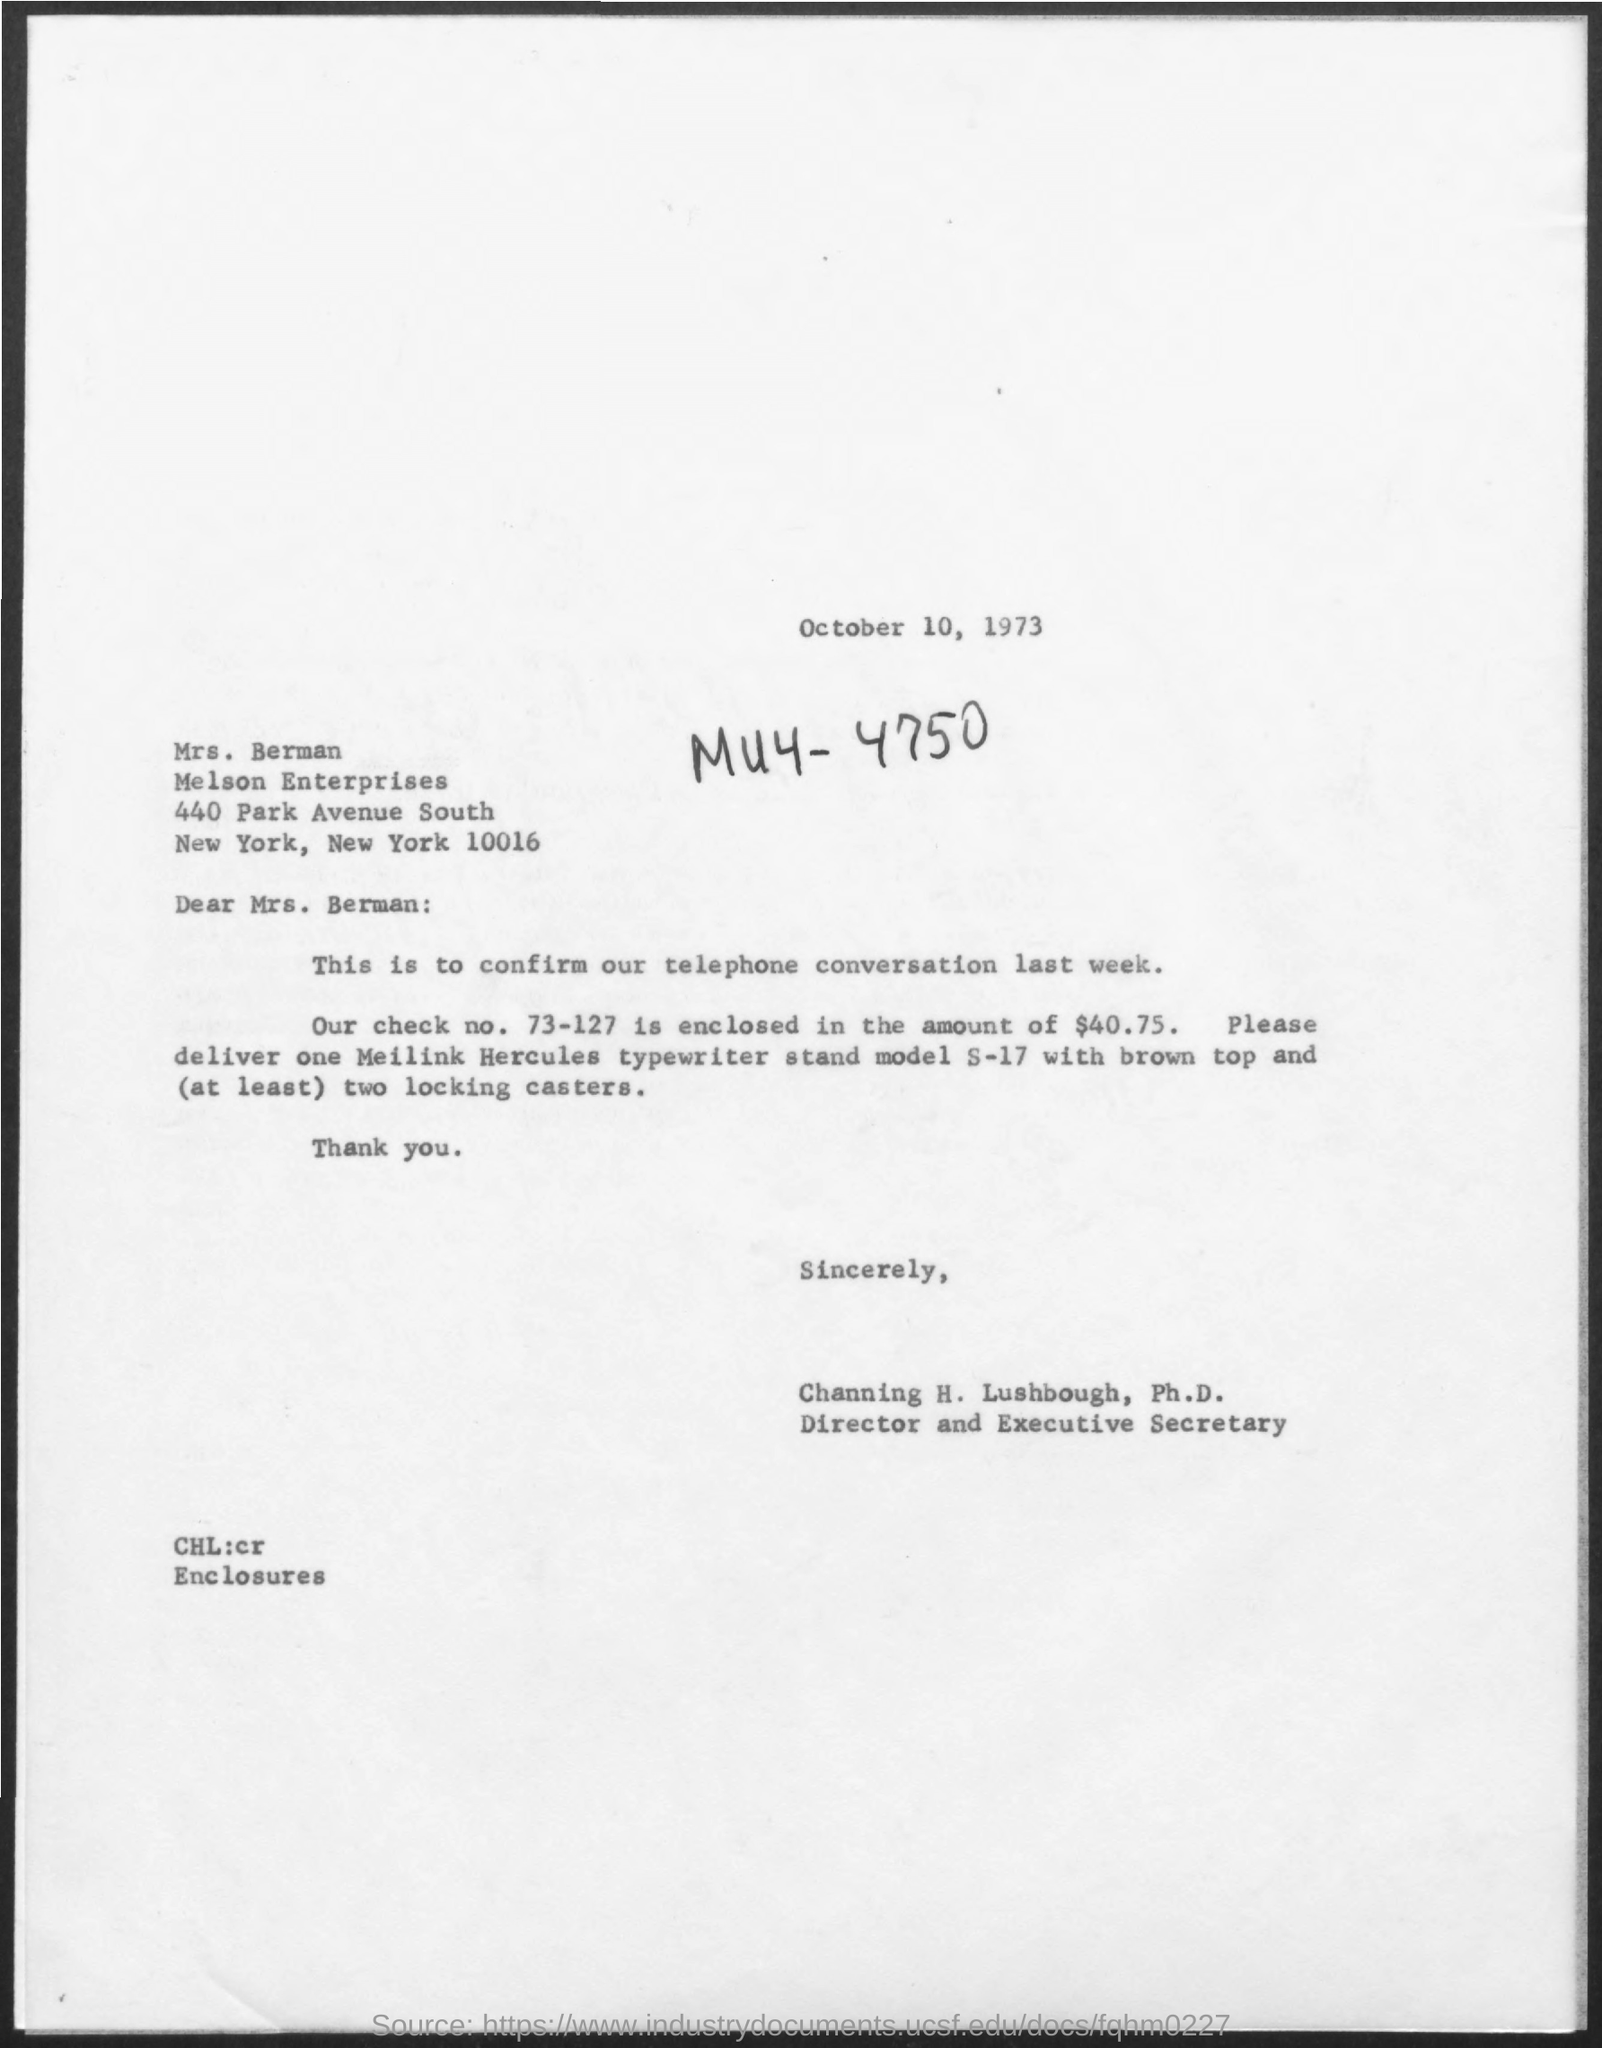What is the date mentioned in the given page ?
Provide a short and direct response. October 10, 1973. What is the name of enterprises mentioned ?
Your answer should be compact. Melson enterprises. To whom the letter was sent ?
Make the answer very short. Mrs. berman. What is the designation of channing h. lushbough ?
Offer a very short reply. Director and executive secretary. What is the check no. mentioned ?
Your answer should be compact. 73-127. What is the amount enclosed in the check ?
Ensure brevity in your answer.  $40.75. 